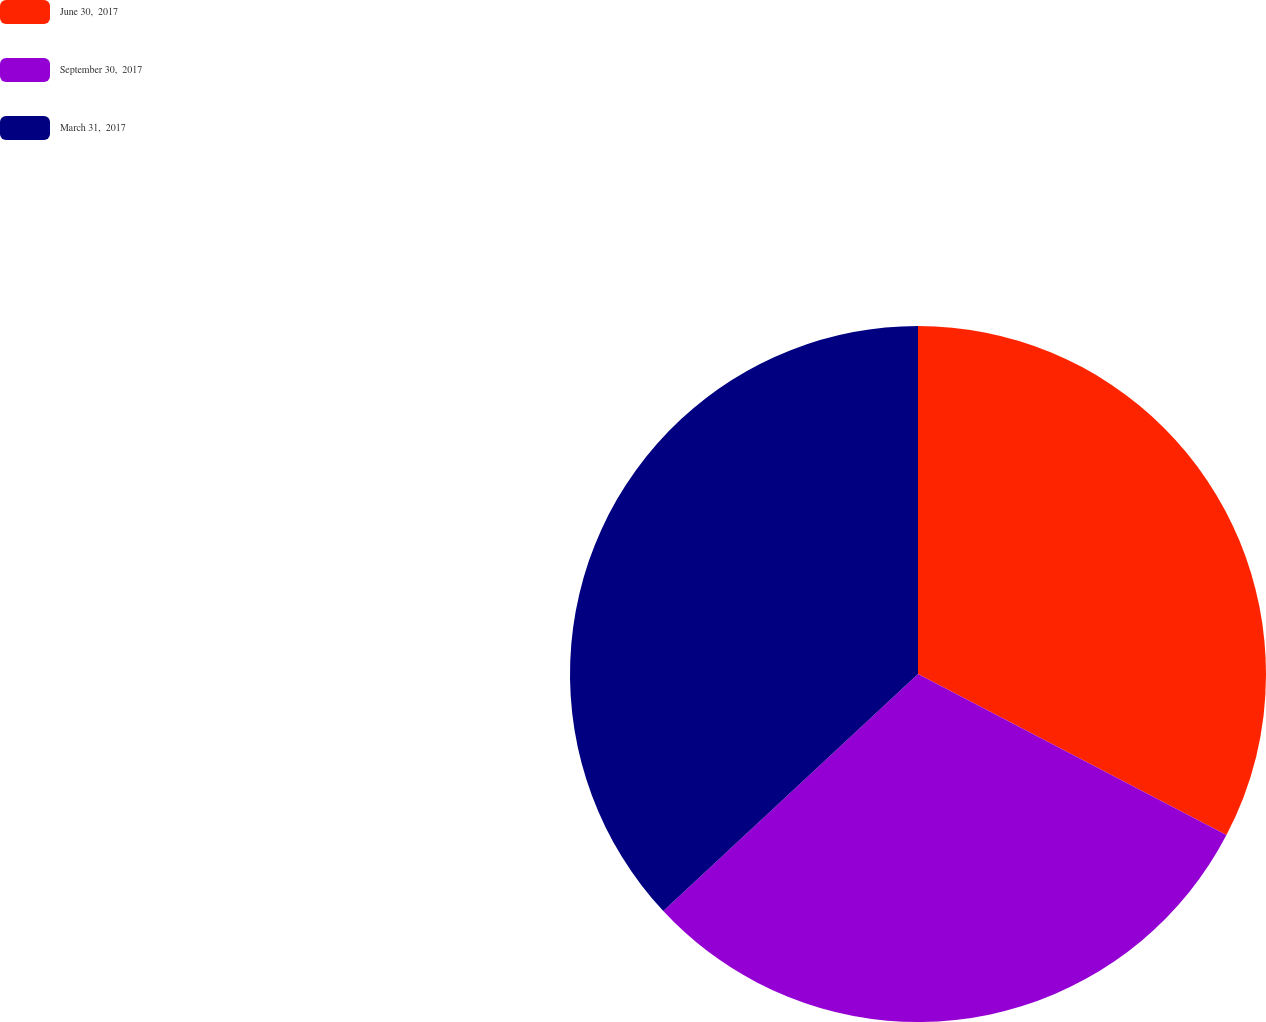Convert chart. <chart><loc_0><loc_0><loc_500><loc_500><pie_chart><fcel>June 30,  2017<fcel>September 30,  2017<fcel>March 31,  2017<nl><fcel>32.66%<fcel>30.41%<fcel>36.93%<nl></chart> 